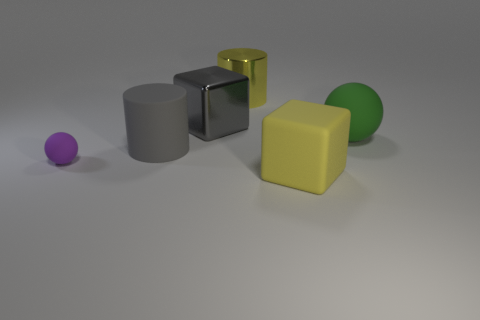What number of things are tiny yellow rubber objects or yellow blocks?
Your answer should be compact. 1. What shape is the green matte thing that is the same size as the shiny cylinder?
Provide a succinct answer. Sphere. What number of things are right of the big gray cylinder and on the left side of the yellow block?
Give a very brief answer. 2. What is the material of the yellow object that is behind the purple thing?
Give a very brief answer. Metal. There is a yellow object that is made of the same material as the gray cube; what is its size?
Offer a terse response. Large. There is a metal block that is on the left side of the big yellow cylinder; is it the same size as the matte object in front of the purple rubber sphere?
Your answer should be compact. Yes. There is another block that is the same size as the yellow cube; what material is it?
Make the answer very short. Metal. There is a object that is both behind the rubber cylinder and left of the big yellow shiny cylinder; what is its material?
Your answer should be very brief. Metal. Is there a large rubber object?
Your answer should be very brief. Yes. There is a tiny ball; is its color the same as the large cube to the right of the metallic cube?
Your answer should be compact. No. 